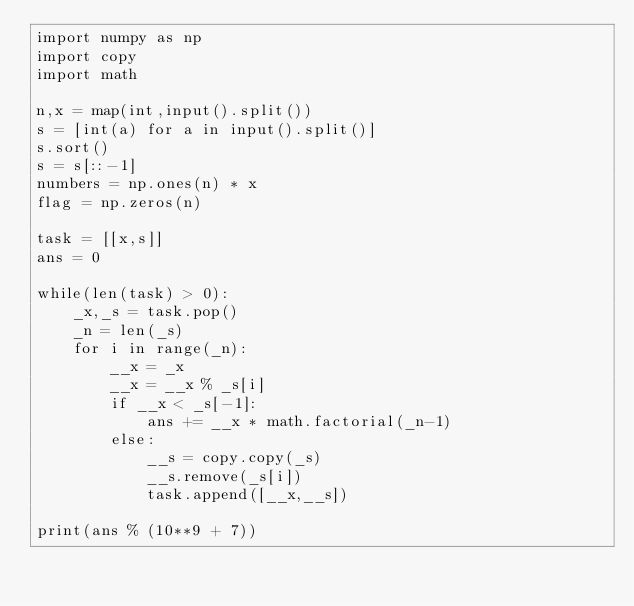Convert code to text. <code><loc_0><loc_0><loc_500><loc_500><_Python_>import numpy as np
import copy
import math

n,x = map(int,input().split())
s = [int(a) for a in input().split()]
s.sort()
s = s[::-1]
numbers = np.ones(n) * x
flag = np.zeros(n)

task = [[x,s]]
ans = 0

while(len(task) > 0):
    _x,_s = task.pop()
    _n = len(_s)
    for i in range(_n):
        __x = _x
        __x = __x % _s[i]
        if __x < _s[-1]:
            ans += __x * math.factorial(_n-1)
        else:
            __s = copy.copy(_s)
            __s.remove(_s[i])
            task.append([__x,__s])

print(ans % (10**9 + 7))

</code> 